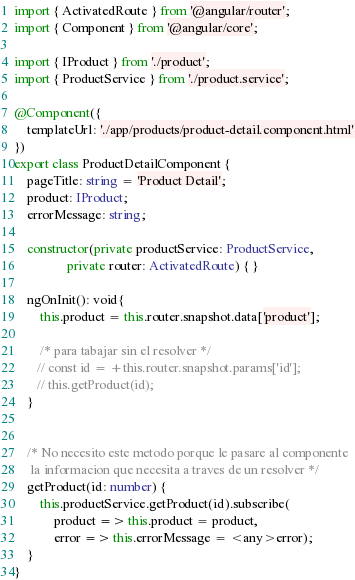Convert code to text. <code><loc_0><loc_0><loc_500><loc_500><_TypeScript_>import { ActivatedRoute } from '@angular/router';
import { Component } from '@angular/core';

import { IProduct } from './product';
import { ProductService } from './product.service';

@Component({
    templateUrl: './app/products/product-detail.component.html'
})
export class ProductDetailComponent {
    pageTitle: string = 'Product Detail';
    product: IProduct;
    errorMessage: string;

    constructor(private productService: ProductService,
                private router: ActivatedRoute) { }

    ngOnInit(): void{
        this.product = this.router.snapshot.data['product'];

        /* para tabajar sin el resolver */
       // const id = +this.router.snapshot.params['id'];         
       // this.getProduct(id);
    }


    /* No necesito este metodo porque le pasare al componente
     la informacion que necesita a traves de un resolver */
    getProduct(id: number) {
        this.productService.getProduct(id).subscribe(
            product => this.product = product,
            error => this.errorMessage = <any>error);
    }
}
</code> 